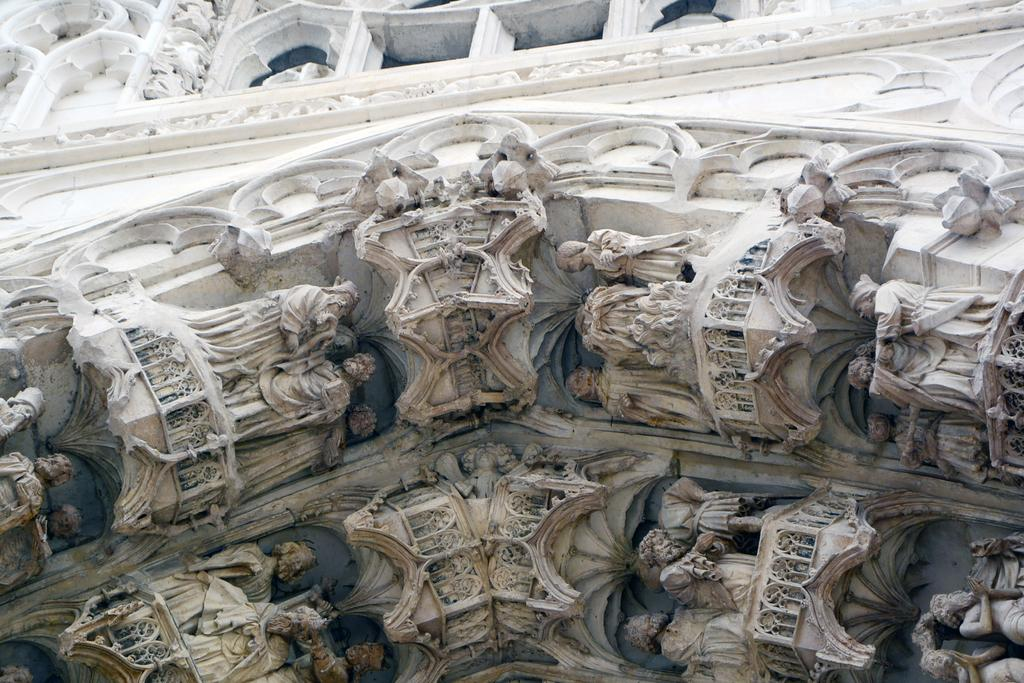What is present on the wall in the image? There are statues and designs on the wall in the image. Can you describe the statues on the wall? The statues on the wall are visible but not described in detail, as the provided facts only mention their presence. What type of designs can be seen on the wall? The designs on the wall are visible but not described in detail, as the provided facts only mention their presence. What type of card is being used to reward the tent in the image? There is no card or tent present in the image; it only features a wall with statues and designs. 